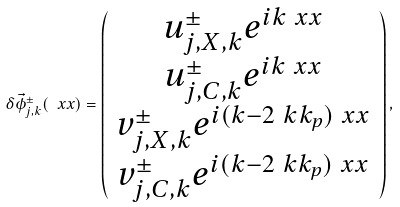Convert formula to latex. <formula><loc_0><loc_0><loc_500><loc_500>\delta { \vec { \phi } ^ { \pm } _ { j , { k } } } ( \ x x ) = \left ( \begin{array} { c } u ^ { \pm } _ { j , X , { k } } e ^ { i { k } \ x x } \\ u ^ { \pm } _ { j , C , { k } } e ^ { i { k } \ x x } \\ v ^ { \pm } _ { j , X , { k } } e ^ { i ( { k } - 2 \ k k _ { p } ) \ x x } \\ v ^ { \pm } _ { j , C , { k } } e ^ { i ( { k } - 2 \ k k _ { p } ) \ x x } \end{array} \right ) ,</formula> 